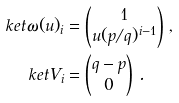<formula> <loc_0><loc_0><loc_500><loc_500>\ k e t { \omega ( u ) } _ { i } & = \begin{pmatrix} 1 \\ u ( p / q ) ^ { i - 1 } \end{pmatrix} \, , \\ \ k e t { V } _ { i } & = \begin{pmatrix} q - p \\ 0 \end{pmatrix} \, .</formula> 